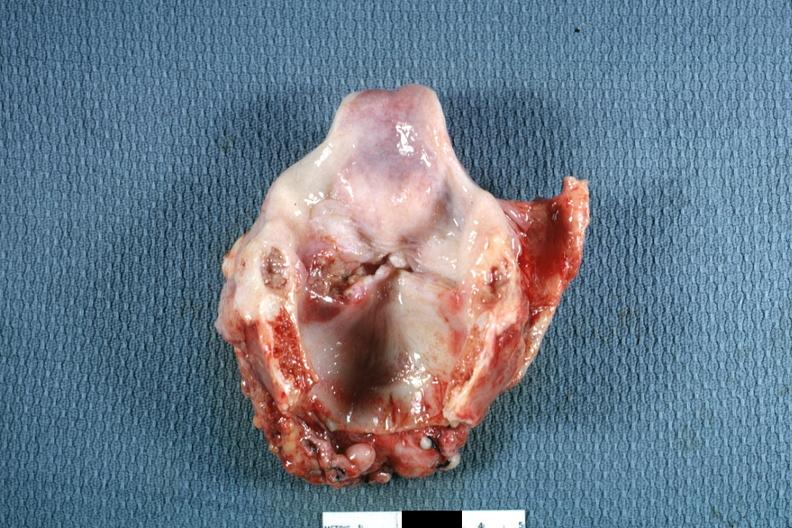what left true cord quite good?
Answer the question using a single word or phrase. Ulcerative lesion 